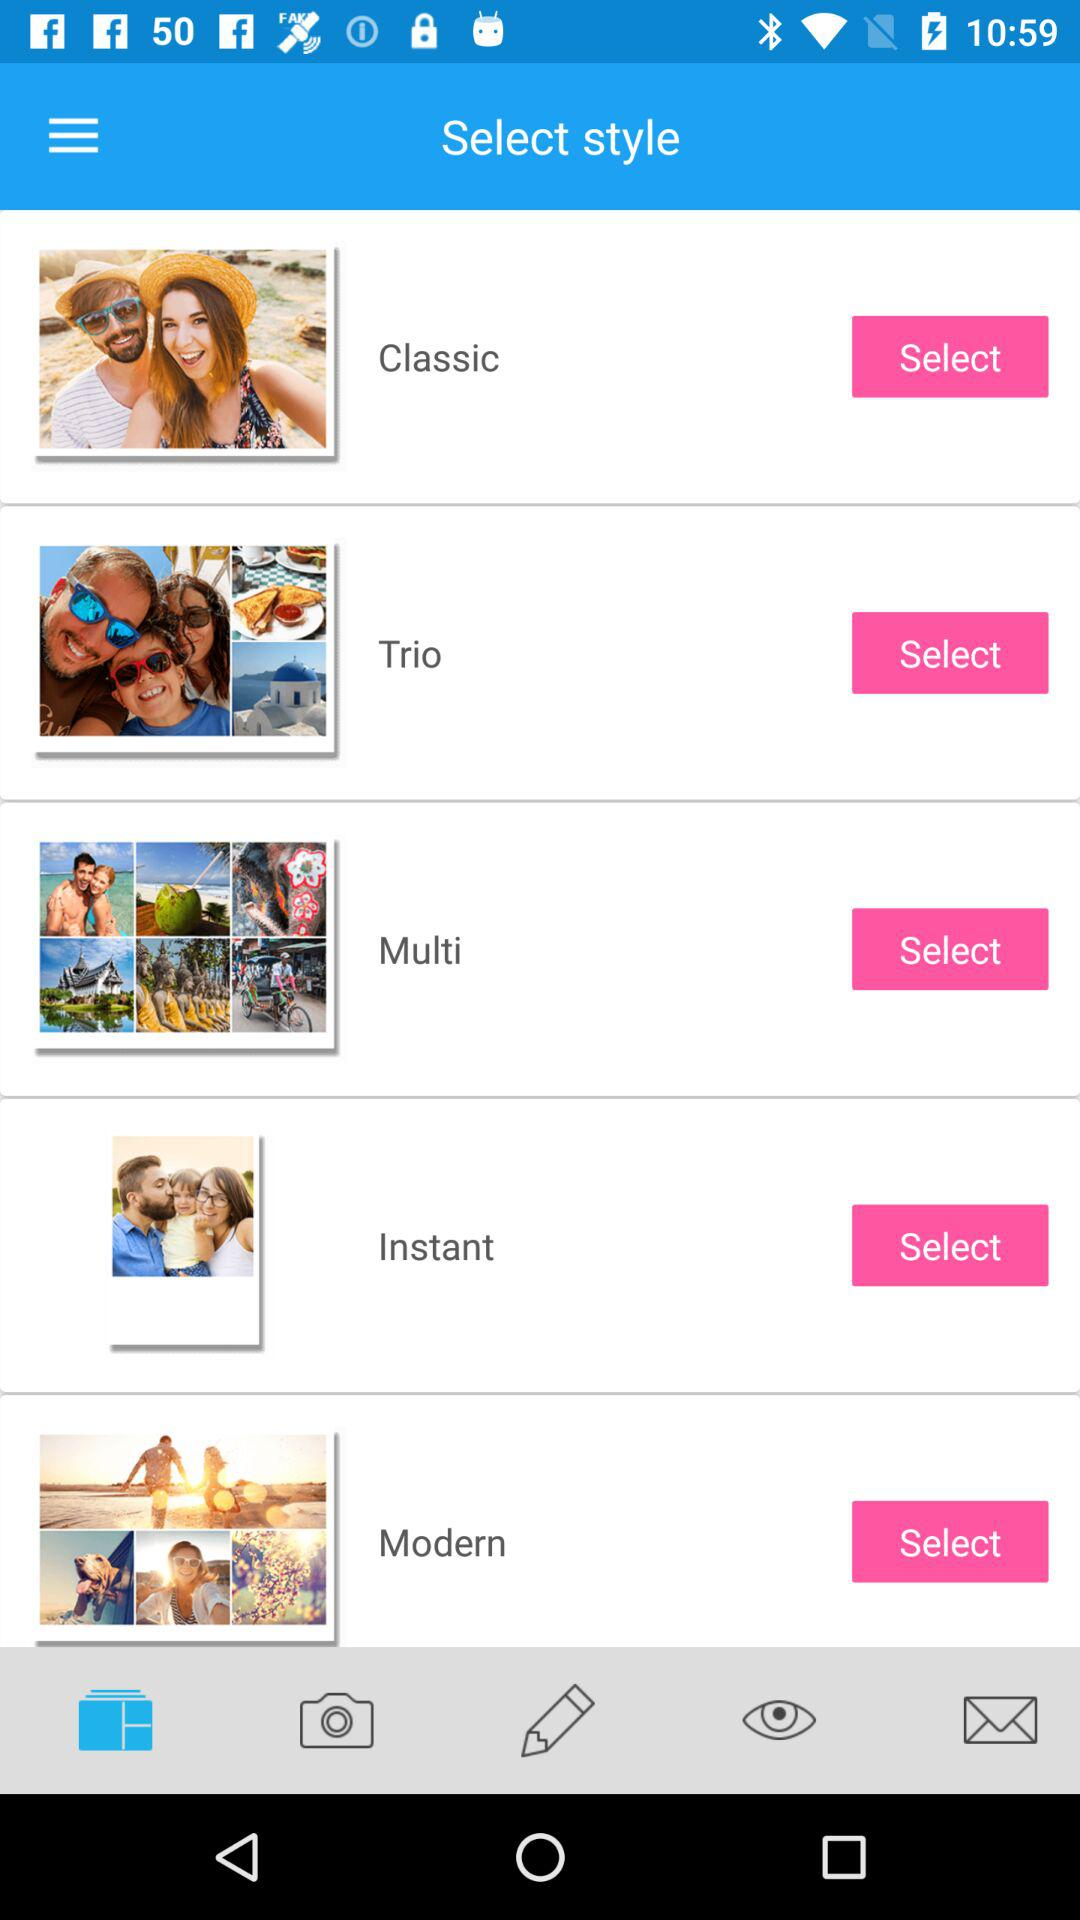How many photos are included in the Modern style?
Answer the question using a single word or phrase. 4 